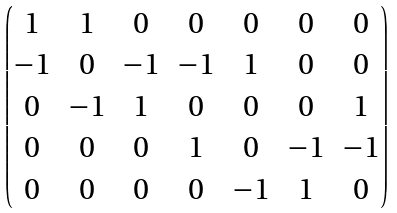Convert formula to latex. <formula><loc_0><loc_0><loc_500><loc_500>\begin{pmatrix} 1 & 1 & 0 & 0 & 0 & 0 & 0 \\ - 1 & 0 & - 1 & - 1 & 1 & 0 & 0 \\ 0 & - 1 & 1 & 0 & 0 & 0 & 1 \\ 0 & 0 & 0 & 1 & 0 & - 1 & - 1 \\ 0 & 0 & 0 & 0 & - 1 & 1 & 0 \end{pmatrix}</formula> 